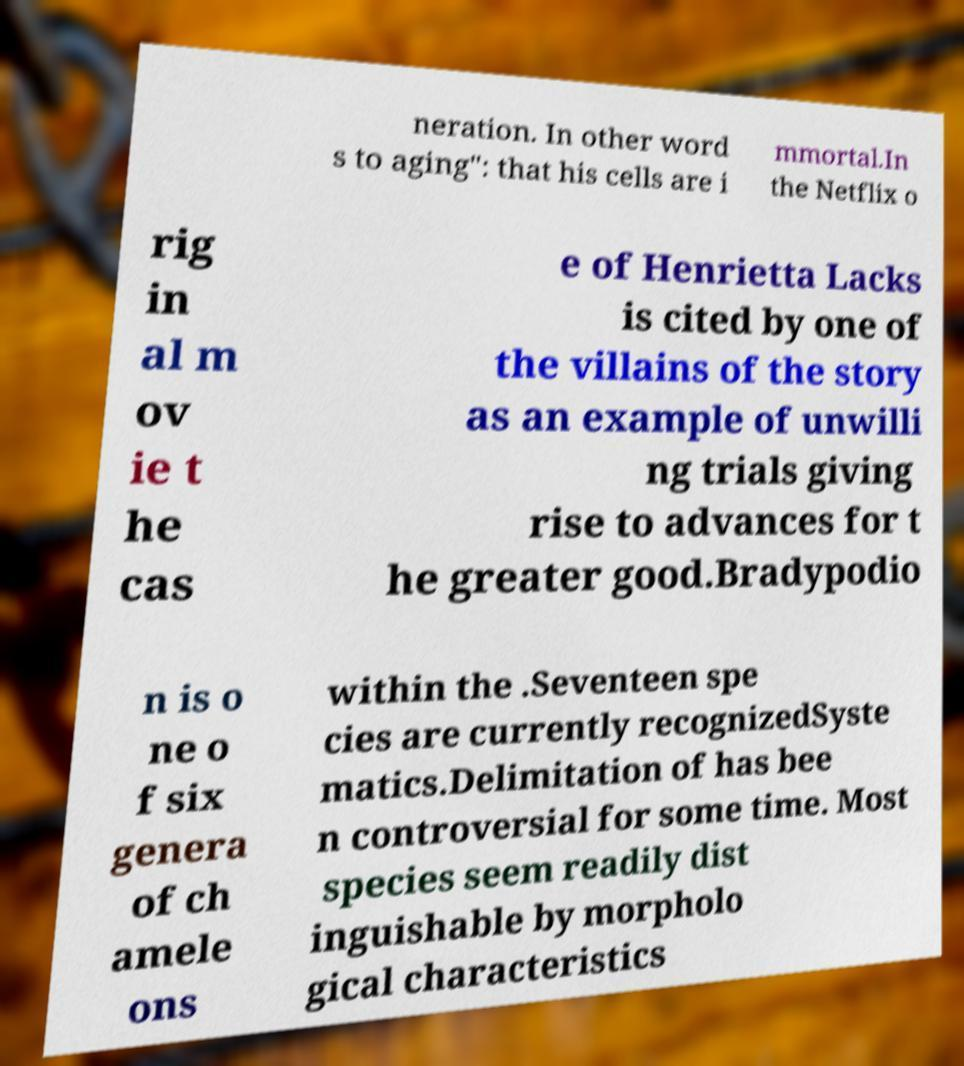I need the written content from this picture converted into text. Can you do that? neration. In other word s to aging": that his cells are i mmortal.In the Netflix o rig in al m ov ie t he cas e of Henrietta Lacks is cited by one of the villains of the story as an example of unwilli ng trials giving rise to advances for t he greater good.Bradypodio n is o ne o f six genera of ch amele ons within the .Seventeen spe cies are currently recognizedSyste matics.Delimitation of has bee n controversial for some time. Most species seem readily dist inguishable by morpholo gical characteristics 